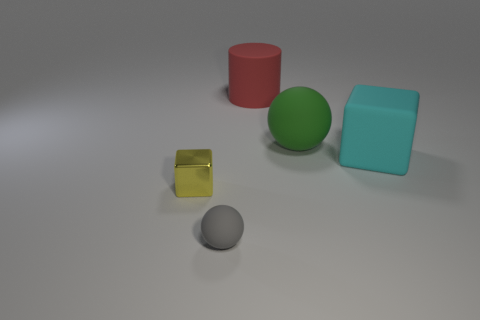What shape is the big cyan matte object? cube 